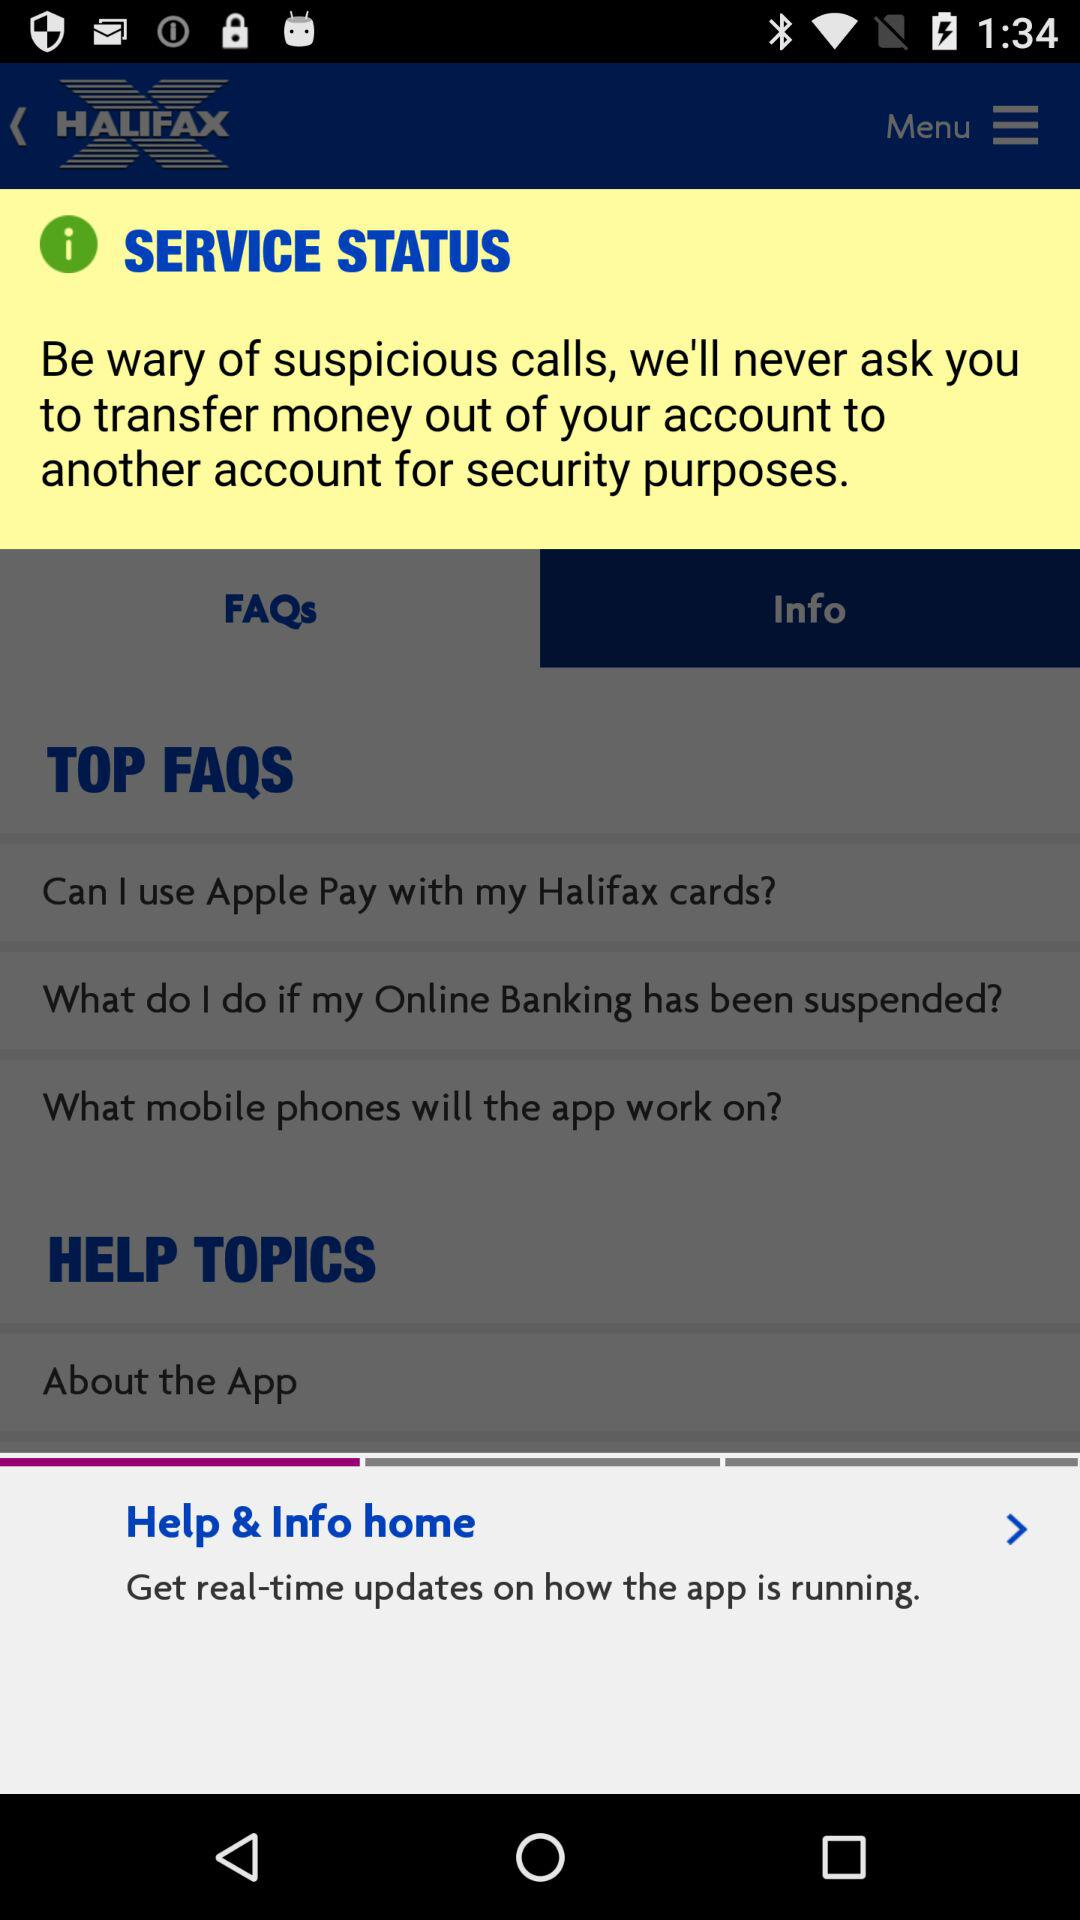How many more FAQs are there than Help Topics?
Answer the question using a single word or phrase. 2 